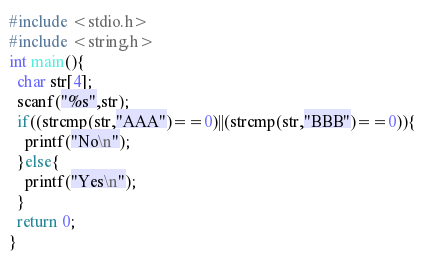<code> <loc_0><loc_0><loc_500><loc_500><_C_>#include <stdio.h>
#include <string.h>
int main(){
  char str[4];
  scanf("%s",str);
  if((strcmp(str,"AAA")==0)||(strcmp(str,"BBB")==0)){
    printf("No\n");
  }else{
    printf("Yes\n");
  }
  return 0;
}</code> 